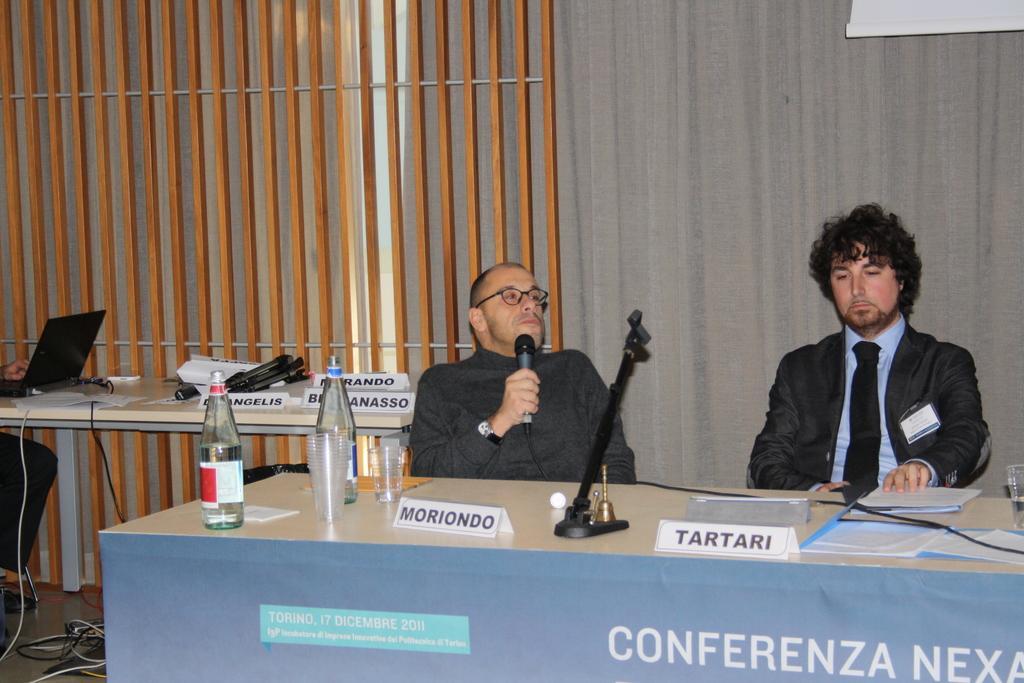In one or two sentences, can you explain what this image depicts? In this image I can see two men are sitting next to a table, here on this table I can see a stand, few bottles and number of glasses. Here I can see he is wearing a specs and holding a mic. I can also see one more person with a laptop. 